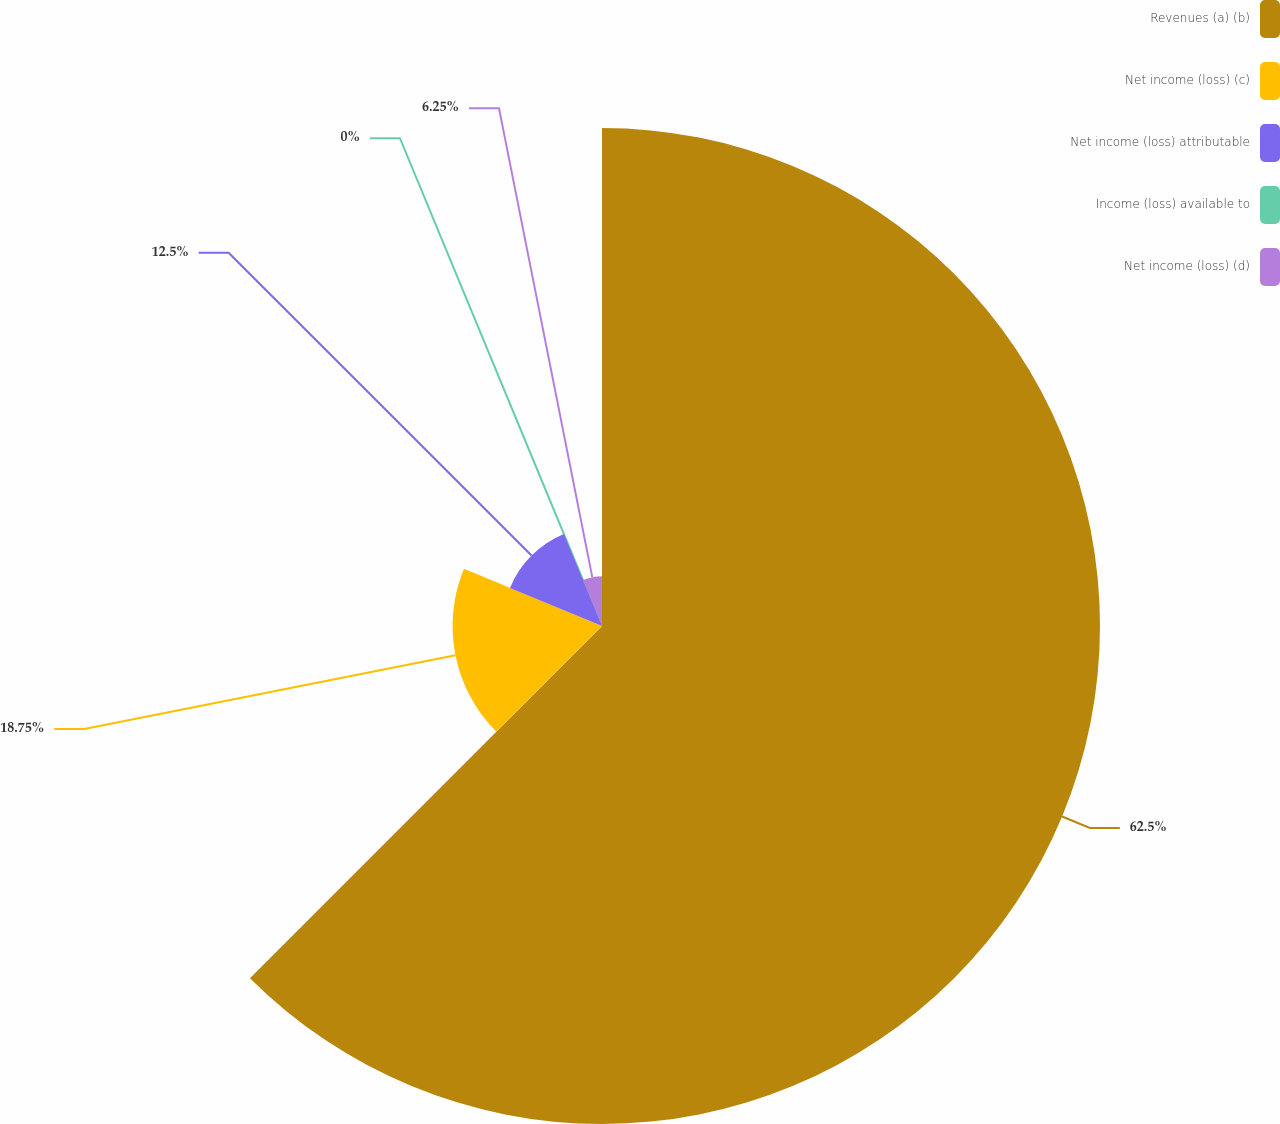Convert chart to OTSL. <chart><loc_0><loc_0><loc_500><loc_500><pie_chart><fcel>Revenues (a) (b)<fcel>Net income (loss) (c)<fcel>Net income (loss) attributable<fcel>Income (loss) available to<fcel>Net income (loss) (d)<nl><fcel>62.49%<fcel>18.75%<fcel>12.5%<fcel>0.0%<fcel>6.25%<nl></chart> 